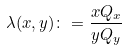Convert formula to latex. <formula><loc_0><loc_0><loc_500><loc_500>\lambda ( x , y ) \colon = \frac { x Q _ { x } } { y Q _ { y } }</formula> 